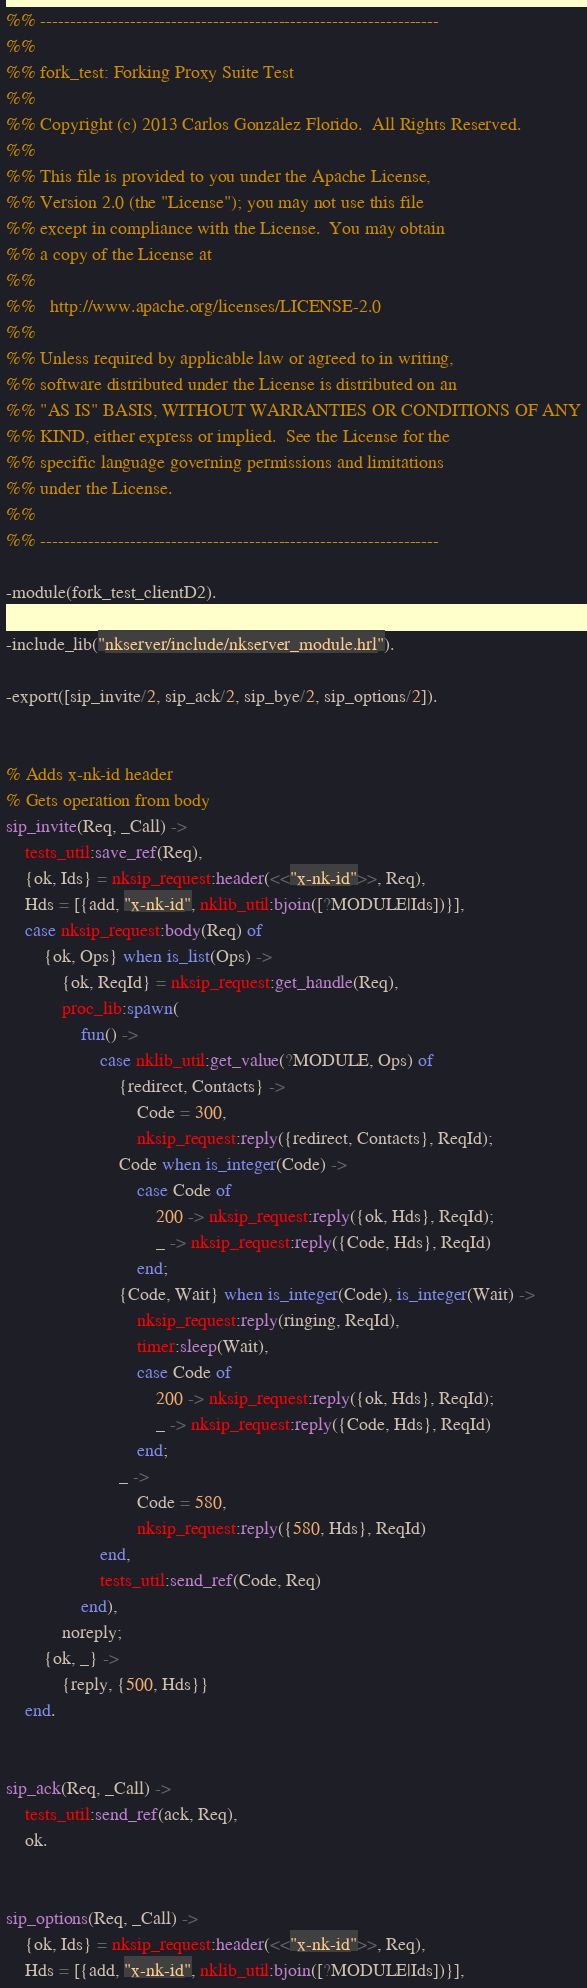Convert code to text. <code><loc_0><loc_0><loc_500><loc_500><_Erlang_>%% -------------------------------------------------------------------
%%
%% fork_test: Forking Proxy Suite Test
%%
%% Copyright (c) 2013 Carlos Gonzalez Florido.  All Rights Reserved.
%%
%% This file is provided to you under the Apache License,
%% Version 2.0 (the "License"); you may not use this file
%% except in compliance with the License.  You may obtain
%% a copy of the License at
%%
%%   http://www.apache.org/licenses/LICENSE-2.0
%%
%% Unless required by applicable law or agreed to in writing,
%% software distributed under the License is distributed on an
%% "AS IS" BASIS, WITHOUT WARRANTIES OR CONDITIONS OF ANY
%% KIND, either express or implied.  See the License for the
%% specific language governing permissions and limitations
%% under the License.
%%
%% -------------------------------------------------------------------

-module(fork_test_clientD2).

-include_lib("nkserver/include/nkserver_module.hrl").

-export([sip_invite/2, sip_ack/2, sip_bye/2, sip_options/2]).


% Adds x-nk-id header
% Gets operation from body
sip_invite(Req, _Call) ->
    tests_util:save_ref(Req),
    {ok, Ids} = nksip_request:header(<<"x-nk-id">>, Req),
    Hds = [{add, "x-nk-id", nklib_util:bjoin([?MODULE|Ids])}],
    case nksip_request:body(Req) of
        {ok, Ops} when is_list(Ops) ->
            {ok, ReqId} = nksip_request:get_handle(Req),
            proc_lib:spawn(
                fun() ->
                    case nklib_util:get_value(?MODULE, Ops) of
                        {redirect, Contacts} ->
                            Code = 300,
                            nksip_request:reply({redirect, Contacts}, ReqId);
                        Code when is_integer(Code) -> 
                            case Code of
                                200 -> nksip_request:reply({ok, Hds}, ReqId);
                                _ -> nksip_request:reply({Code, Hds}, ReqId)
                            end;
                        {Code, Wait} when is_integer(Code), is_integer(Wait) ->
                            nksip_request:reply(ringing, ReqId),
                            timer:sleep(Wait),
                            case Code of
                                200 -> nksip_request:reply({ok, Hds}, ReqId);
                                _ -> nksip_request:reply({Code, Hds}, ReqId)
                            end;
                        _ -> 
                            Code = 580,
                            nksip_request:reply({580, Hds}, ReqId)
                    end,
                    tests_util:send_ref(Code, Req)
                end),
            noreply;
        {ok, _} ->
            {reply, {500, Hds}}
    end.


sip_ack(Req, _Call) ->
    tests_util:send_ref(ack, Req),
    ok.


sip_options(Req, _Call) ->
    {ok, Ids} = nksip_request:header(<<"x-nk-id">>, Req),
    Hds = [{add, "x-nk-id", nklib_util:bjoin([?MODULE|Ids])}],</code> 